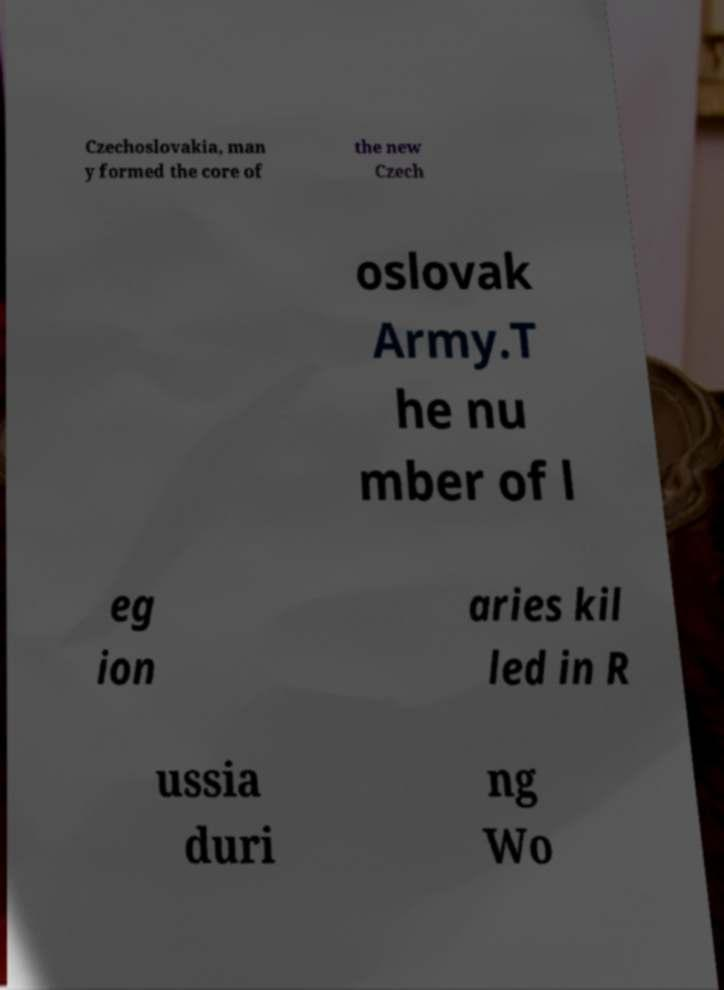Can you accurately transcribe the text from the provided image for me? Czechoslovakia, man y formed the core of the new Czech oslovak Army.T he nu mber of l eg ion aries kil led in R ussia duri ng Wo 